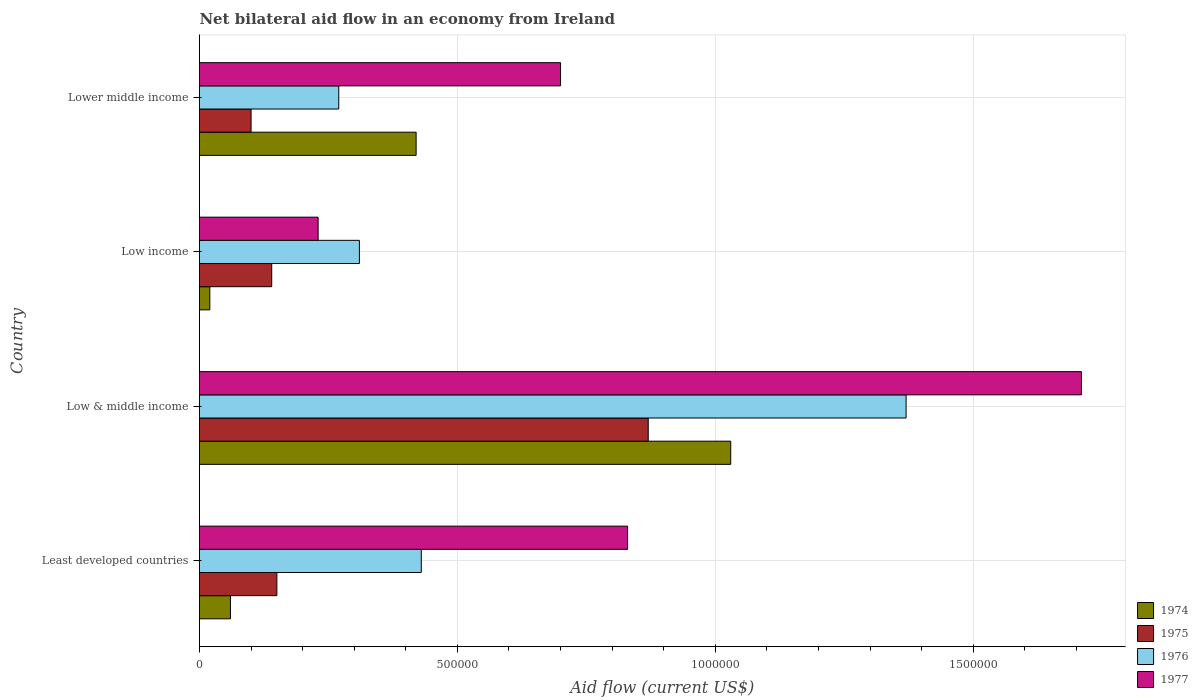How many different coloured bars are there?
Ensure brevity in your answer.  4. What is the label of the 3rd group of bars from the top?
Give a very brief answer. Low & middle income. Across all countries, what is the maximum net bilateral aid flow in 1976?
Your response must be concise. 1.37e+06. Across all countries, what is the minimum net bilateral aid flow in 1975?
Offer a very short reply. 1.00e+05. In which country was the net bilateral aid flow in 1975 minimum?
Your answer should be compact. Lower middle income. What is the total net bilateral aid flow in 1974 in the graph?
Give a very brief answer. 1.53e+06. What is the difference between the net bilateral aid flow in 1974 in Least developed countries and that in Lower middle income?
Ensure brevity in your answer.  -3.60e+05. What is the difference between the net bilateral aid flow in 1974 in Lower middle income and the net bilateral aid flow in 1975 in Low & middle income?
Offer a terse response. -4.50e+05. What is the average net bilateral aid flow in 1977 per country?
Offer a very short reply. 8.68e+05. What is the difference between the net bilateral aid flow in 1976 and net bilateral aid flow in 1975 in Low income?
Offer a terse response. 1.70e+05. What is the ratio of the net bilateral aid flow in 1977 in Low income to that in Lower middle income?
Keep it short and to the point. 0.33. Is the net bilateral aid flow in 1976 in Least developed countries less than that in Low income?
Provide a succinct answer. No. What is the difference between the highest and the second highest net bilateral aid flow in 1975?
Give a very brief answer. 7.20e+05. What is the difference between the highest and the lowest net bilateral aid flow in 1974?
Offer a terse response. 1.01e+06. In how many countries, is the net bilateral aid flow in 1976 greater than the average net bilateral aid flow in 1976 taken over all countries?
Ensure brevity in your answer.  1. What does the 2nd bar from the bottom in Least developed countries represents?
Your response must be concise. 1975. How many bars are there?
Your answer should be compact. 16. Are all the bars in the graph horizontal?
Your response must be concise. Yes. Are the values on the major ticks of X-axis written in scientific E-notation?
Provide a succinct answer. No. Does the graph contain grids?
Your answer should be compact. Yes. Where does the legend appear in the graph?
Offer a very short reply. Bottom right. How many legend labels are there?
Your answer should be compact. 4. How are the legend labels stacked?
Your answer should be very brief. Vertical. What is the title of the graph?
Your answer should be very brief. Net bilateral aid flow in an economy from Ireland. What is the Aid flow (current US$) of 1974 in Least developed countries?
Offer a terse response. 6.00e+04. What is the Aid flow (current US$) of 1977 in Least developed countries?
Your response must be concise. 8.30e+05. What is the Aid flow (current US$) of 1974 in Low & middle income?
Your answer should be compact. 1.03e+06. What is the Aid flow (current US$) of 1975 in Low & middle income?
Give a very brief answer. 8.70e+05. What is the Aid flow (current US$) of 1976 in Low & middle income?
Give a very brief answer. 1.37e+06. What is the Aid flow (current US$) of 1977 in Low & middle income?
Provide a succinct answer. 1.71e+06. What is the Aid flow (current US$) of 1975 in Low income?
Provide a succinct answer. 1.40e+05. What is the Aid flow (current US$) of 1976 in Low income?
Offer a terse response. 3.10e+05. What is the Aid flow (current US$) of 1977 in Low income?
Make the answer very short. 2.30e+05. What is the Aid flow (current US$) in 1975 in Lower middle income?
Your answer should be compact. 1.00e+05. What is the Aid flow (current US$) of 1977 in Lower middle income?
Your answer should be very brief. 7.00e+05. Across all countries, what is the maximum Aid flow (current US$) of 1974?
Make the answer very short. 1.03e+06. Across all countries, what is the maximum Aid flow (current US$) of 1975?
Your answer should be very brief. 8.70e+05. Across all countries, what is the maximum Aid flow (current US$) of 1976?
Your answer should be compact. 1.37e+06. Across all countries, what is the maximum Aid flow (current US$) of 1977?
Your answer should be compact. 1.71e+06. Across all countries, what is the minimum Aid flow (current US$) of 1974?
Your answer should be very brief. 2.00e+04. Across all countries, what is the minimum Aid flow (current US$) in 1975?
Keep it short and to the point. 1.00e+05. Across all countries, what is the minimum Aid flow (current US$) of 1976?
Provide a succinct answer. 2.70e+05. Across all countries, what is the minimum Aid flow (current US$) of 1977?
Provide a short and direct response. 2.30e+05. What is the total Aid flow (current US$) in 1974 in the graph?
Keep it short and to the point. 1.53e+06. What is the total Aid flow (current US$) of 1975 in the graph?
Give a very brief answer. 1.26e+06. What is the total Aid flow (current US$) in 1976 in the graph?
Make the answer very short. 2.38e+06. What is the total Aid flow (current US$) in 1977 in the graph?
Your answer should be compact. 3.47e+06. What is the difference between the Aid flow (current US$) in 1974 in Least developed countries and that in Low & middle income?
Offer a very short reply. -9.70e+05. What is the difference between the Aid flow (current US$) of 1975 in Least developed countries and that in Low & middle income?
Your answer should be compact. -7.20e+05. What is the difference between the Aid flow (current US$) of 1976 in Least developed countries and that in Low & middle income?
Offer a terse response. -9.40e+05. What is the difference between the Aid flow (current US$) in 1977 in Least developed countries and that in Low & middle income?
Make the answer very short. -8.80e+05. What is the difference between the Aid flow (current US$) in 1977 in Least developed countries and that in Low income?
Keep it short and to the point. 6.00e+05. What is the difference between the Aid flow (current US$) in 1974 in Least developed countries and that in Lower middle income?
Your answer should be very brief. -3.60e+05. What is the difference between the Aid flow (current US$) in 1975 in Least developed countries and that in Lower middle income?
Your answer should be very brief. 5.00e+04. What is the difference between the Aid flow (current US$) of 1976 in Least developed countries and that in Lower middle income?
Your answer should be very brief. 1.60e+05. What is the difference between the Aid flow (current US$) in 1977 in Least developed countries and that in Lower middle income?
Your response must be concise. 1.30e+05. What is the difference between the Aid flow (current US$) in 1974 in Low & middle income and that in Low income?
Ensure brevity in your answer.  1.01e+06. What is the difference between the Aid flow (current US$) of 1975 in Low & middle income and that in Low income?
Provide a short and direct response. 7.30e+05. What is the difference between the Aid flow (current US$) of 1976 in Low & middle income and that in Low income?
Provide a short and direct response. 1.06e+06. What is the difference between the Aid flow (current US$) of 1977 in Low & middle income and that in Low income?
Keep it short and to the point. 1.48e+06. What is the difference between the Aid flow (current US$) of 1975 in Low & middle income and that in Lower middle income?
Your answer should be compact. 7.70e+05. What is the difference between the Aid flow (current US$) in 1976 in Low & middle income and that in Lower middle income?
Offer a very short reply. 1.10e+06. What is the difference between the Aid flow (current US$) in 1977 in Low & middle income and that in Lower middle income?
Your answer should be compact. 1.01e+06. What is the difference between the Aid flow (current US$) of 1974 in Low income and that in Lower middle income?
Your response must be concise. -4.00e+05. What is the difference between the Aid flow (current US$) in 1977 in Low income and that in Lower middle income?
Your answer should be very brief. -4.70e+05. What is the difference between the Aid flow (current US$) in 1974 in Least developed countries and the Aid flow (current US$) in 1975 in Low & middle income?
Your response must be concise. -8.10e+05. What is the difference between the Aid flow (current US$) of 1974 in Least developed countries and the Aid flow (current US$) of 1976 in Low & middle income?
Give a very brief answer. -1.31e+06. What is the difference between the Aid flow (current US$) in 1974 in Least developed countries and the Aid flow (current US$) in 1977 in Low & middle income?
Provide a succinct answer. -1.65e+06. What is the difference between the Aid flow (current US$) in 1975 in Least developed countries and the Aid flow (current US$) in 1976 in Low & middle income?
Offer a terse response. -1.22e+06. What is the difference between the Aid flow (current US$) of 1975 in Least developed countries and the Aid flow (current US$) of 1977 in Low & middle income?
Your answer should be very brief. -1.56e+06. What is the difference between the Aid flow (current US$) of 1976 in Least developed countries and the Aid flow (current US$) of 1977 in Low & middle income?
Provide a succinct answer. -1.28e+06. What is the difference between the Aid flow (current US$) of 1974 in Least developed countries and the Aid flow (current US$) of 1975 in Low income?
Offer a very short reply. -8.00e+04. What is the difference between the Aid flow (current US$) in 1975 in Least developed countries and the Aid flow (current US$) in 1976 in Low income?
Offer a terse response. -1.60e+05. What is the difference between the Aid flow (current US$) of 1975 in Least developed countries and the Aid flow (current US$) of 1977 in Low income?
Your response must be concise. -8.00e+04. What is the difference between the Aid flow (current US$) of 1974 in Least developed countries and the Aid flow (current US$) of 1976 in Lower middle income?
Your response must be concise. -2.10e+05. What is the difference between the Aid flow (current US$) of 1974 in Least developed countries and the Aid flow (current US$) of 1977 in Lower middle income?
Keep it short and to the point. -6.40e+05. What is the difference between the Aid flow (current US$) of 1975 in Least developed countries and the Aid flow (current US$) of 1977 in Lower middle income?
Your response must be concise. -5.50e+05. What is the difference between the Aid flow (current US$) in 1976 in Least developed countries and the Aid flow (current US$) in 1977 in Lower middle income?
Offer a terse response. -2.70e+05. What is the difference between the Aid flow (current US$) of 1974 in Low & middle income and the Aid flow (current US$) of 1975 in Low income?
Your answer should be compact. 8.90e+05. What is the difference between the Aid flow (current US$) of 1974 in Low & middle income and the Aid flow (current US$) of 1976 in Low income?
Your answer should be very brief. 7.20e+05. What is the difference between the Aid flow (current US$) of 1975 in Low & middle income and the Aid flow (current US$) of 1976 in Low income?
Provide a short and direct response. 5.60e+05. What is the difference between the Aid flow (current US$) in 1975 in Low & middle income and the Aid flow (current US$) in 1977 in Low income?
Provide a succinct answer. 6.40e+05. What is the difference between the Aid flow (current US$) in 1976 in Low & middle income and the Aid flow (current US$) in 1977 in Low income?
Provide a short and direct response. 1.14e+06. What is the difference between the Aid flow (current US$) in 1974 in Low & middle income and the Aid flow (current US$) in 1975 in Lower middle income?
Give a very brief answer. 9.30e+05. What is the difference between the Aid flow (current US$) in 1974 in Low & middle income and the Aid flow (current US$) in 1976 in Lower middle income?
Your answer should be very brief. 7.60e+05. What is the difference between the Aid flow (current US$) of 1975 in Low & middle income and the Aid flow (current US$) of 1977 in Lower middle income?
Provide a succinct answer. 1.70e+05. What is the difference between the Aid flow (current US$) of 1976 in Low & middle income and the Aid flow (current US$) of 1977 in Lower middle income?
Ensure brevity in your answer.  6.70e+05. What is the difference between the Aid flow (current US$) in 1974 in Low income and the Aid flow (current US$) in 1976 in Lower middle income?
Provide a succinct answer. -2.50e+05. What is the difference between the Aid flow (current US$) of 1974 in Low income and the Aid flow (current US$) of 1977 in Lower middle income?
Your response must be concise. -6.80e+05. What is the difference between the Aid flow (current US$) of 1975 in Low income and the Aid flow (current US$) of 1976 in Lower middle income?
Provide a succinct answer. -1.30e+05. What is the difference between the Aid flow (current US$) of 1975 in Low income and the Aid flow (current US$) of 1977 in Lower middle income?
Provide a succinct answer. -5.60e+05. What is the difference between the Aid flow (current US$) in 1976 in Low income and the Aid flow (current US$) in 1977 in Lower middle income?
Keep it short and to the point. -3.90e+05. What is the average Aid flow (current US$) in 1974 per country?
Ensure brevity in your answer.  3.82e+05. What is the average Aid flow (current US$) in 1975 per country?
Offer a very short reply. 3.15e+05. What is the average Aid flow (current US$) of 1976 per country?
Provide a succinct answer. 5.95e+05. What is the average Aid flow (current US$) in 1977 per country?
Provide a succinct answer. 8.68e+05. What is the difference between the Aid flow (current US$) of 1974 and Aid flow (current US$) of 1976 in Least developed countries?
Ensure brevity in your answer.  -3.70e+05. What is the difference between the Aid flow (current US$) of 1974 and Aid flow (current US$) of 1977 in Least developed countries?
Provide a succinct answer. -7.70e+05. What is the difference between the Aid flow (current US$) in 1975 and Aid flow (current US$) in 1976 in Least developed countries?
Provide a succinct answer. -2.80e+05. What is the difference between the Aid flow (current US$) in 1975 and Aid flow (current US$) in 1977 in Least developed countries?
Your answer should be compact. -6.80e+05. What is the difference between the Aid flow (current US$) of 1976 and Aid flow (current US$) of 1977 in Least developed countries?
Offer a terse response. -4.00e+05. What is the difference between the Aid flow (current US$) of 1974 and Aid flow (current US$) of 1976 in Low & middle income?
Keep it short and to the point. -3.40e+05. What is the difference between the Aid flow (current US$) of 1974 and Aid flow (current US$) of 1977 in Low & middle income?
Give a very brief answer. -6.80e+05. What is the difference between the Aid flow (current US$) in 1975 and Aid flow (current US$) in 1976 in Low & middle income?
Offer a very short reply. -5.00e+05. What is the difference between the Aid flow (current US$) of 1975 and Aid flow (current US$) of 1977 in Low & middle income?
Your response must be concise. -8.40e+05. What is the difference between the Aid flow (current US$) in 1976 and Aid flow (current US$) in 1977 in Low & middle income?
Provide a succinct answer. -3.40e+05. What is the difference between the Aid flow (current US$) in 1974 and Aid flow (current US$) in 1975 in Low income?
Your answer should be very brief. -1.20e+05. What is the difference between the Aid flow (current US$) in 1974 and Aid flow (current US$) in 1976 in Low income?
Make the answer very short. -2.90e+05. What is the difference between the Aid flow (current US$) of 1975 and Aid flow (current US$) of 1977 in Low income?
Provide a succinct answer. -9.00e+04. What is the difference between the Aid flow (current US$) in 1974 and Aid flow (current US$) in 1977 in Lower middle income?
Ensure brevity in your answer.  -2.80e+05. What is the difference between the Aid flow (current US$) in 1975 and Aid flow (current US$) in 1976 in Lower middle income?
Ensure brevity in your answer.  -1.70e+05. What is the difference between the Aid flow (current US$) in 1975 and Aid flow (current US$) in 1977 in Lower middle income?
Your answer should be compact. -6.00e+05. What is the difference between the Aid flow (current US$) of 1976 and Aid flow (current US$) of 1977 in Lower middle income?
Give a very brief answer. -4.30e+05. What is the ratio of the Aid flow (current US$) of 1974 in Least developed countries to that in Low & middle income?
Your answer should be very brief. 0.06. What is the ratio of the Aid flow (current US$) in 1975 in Least developed countries to that in Low & middle income?
Make the answer very short. 0.17. What is the ratio of the Aid flow (current US$) of 1976 in Least developed countries to that in Low & middle income?
Make the answer very short. 0.31. What is the ratio of the Aid flow (current US$) of 1977 in Least developed countries to that in Low & middle income?
Your answer should be compact. 0.49. What is the ratio of the Aid flow (current US$) of 1974 in Least developed countries to that in Low income?
Make the answer very short. 3. What is the ratio of the Aid flow (current US$) in 1975 in Least developed countries to that in Low income?
Your response must be concise. 1.07. What is the ratio of the Aid flow (current US$) of 1976 in Least developed countries to that in Low income?
Give a very brief answer. 1.39. What is the ratio of the Aid flow (current US$) in 1977 in Least developed countries to that in Low income?
Provide a succinct answer. 3.61. What is the ratio of the Aid flow (current US$) in 1974 in Least developed countries to that in Lower middle income?
Ensure brevity in your answer.  0.14. What is the ratio of the Aid flow (current US$) of 1976 in Least developed countries to that in Lower middle income?
Keep it short and to the point. 1.59. What is the ratio of the Aid flow (current US$) of 1977 in Least developed countries to that in Lower middle income?
Your answer should be very brief. 1.19. What is the ratio of the Aid flow (current US$) in 1974 in Low & middle income to that in Low income?
Offer a terse response. 51.5. What is the ratio of the Aid flow (current US$) in 1975 in Low & middle income to that in Low income?
Give a very brief answer. 6.21. What is the ratio of the Aid flow (current US$) in 1976 in Low & middle income to that in Low income?
Your response must be concise. 4.42. What is the ratio of the Aid flow (current US$) in 1977 in Low & middle income to that in Low income?
Your answer should be very brief. 7.43. What is the ratio of the Aid flow (current US$) in 1974 in Low & middle income to that in Lower middle income?
Your answer should be compact. 2.45. What is the ratio of the Aid flow (current US$) in 1975 in Low & middle income to that in Lower middle income?
Offer a terse response. 8.7. What is the ratio of the Aid flow (current US$) of 1976 in Low & middle income to that in Lower middle income?
Offer a terse response. 5.07. What is the ratio of the Aid flow (current US$) of 1977 in Low & middle income to that in Lower middle income?
Offer a terse response. 2.44. What is the ratio of the Aid flow (current US$) in 1974 in Low income to that in Lower middle income?
Your answer should be very brief. 0.05. What is the ratio of the Aid flow (current US$) of 1975 in Low income to that in Lower middle income?
Provide a short and direct response. 1.4. What is the ratio of the Aid flow (current US$) in 1976 in Low income to that in Lower middle income?
Your response must be concise. 1.15. What is the ratio of the Aid flow (current US$) of 1977 in Low income to that in Lower middle income?
Your response must be concise. 0.33. What is the difference between the highest and the second highest Aid flow (current US$) of 1974?
Offer a terse response. 6.10e+05. What is the difference between the highest and the second highest Aid flow (current US$) of 1975?
Your answer should be compact. 7.20e+05. What is the difference between the highest and the second highest Aid flow (current US$) of 1976?
Provide a short and direct response. 9.40e+05. What is the difference between the highest and the second highest Aid flow (current US$) of 1977?
Your response must be concise. 8.80e+05. What is the difference between the highest and the lowest Aid flow (current US$) in 1974?
Provide a short and direct response. 1.01e+06. What is the difference between the highest and the lowest Aid flow (current US$) in 1975?
Your answer should be compact. 7.70e+05. What is the difference between the highest and the lowest Aid flow (current US$) of 1976?
Your response must be concise. 1.10e+06. What is the difference between the highest and the lowest Aid flow (current US$) of 1977?
Provide a short and direct response. 1.48e+06. 